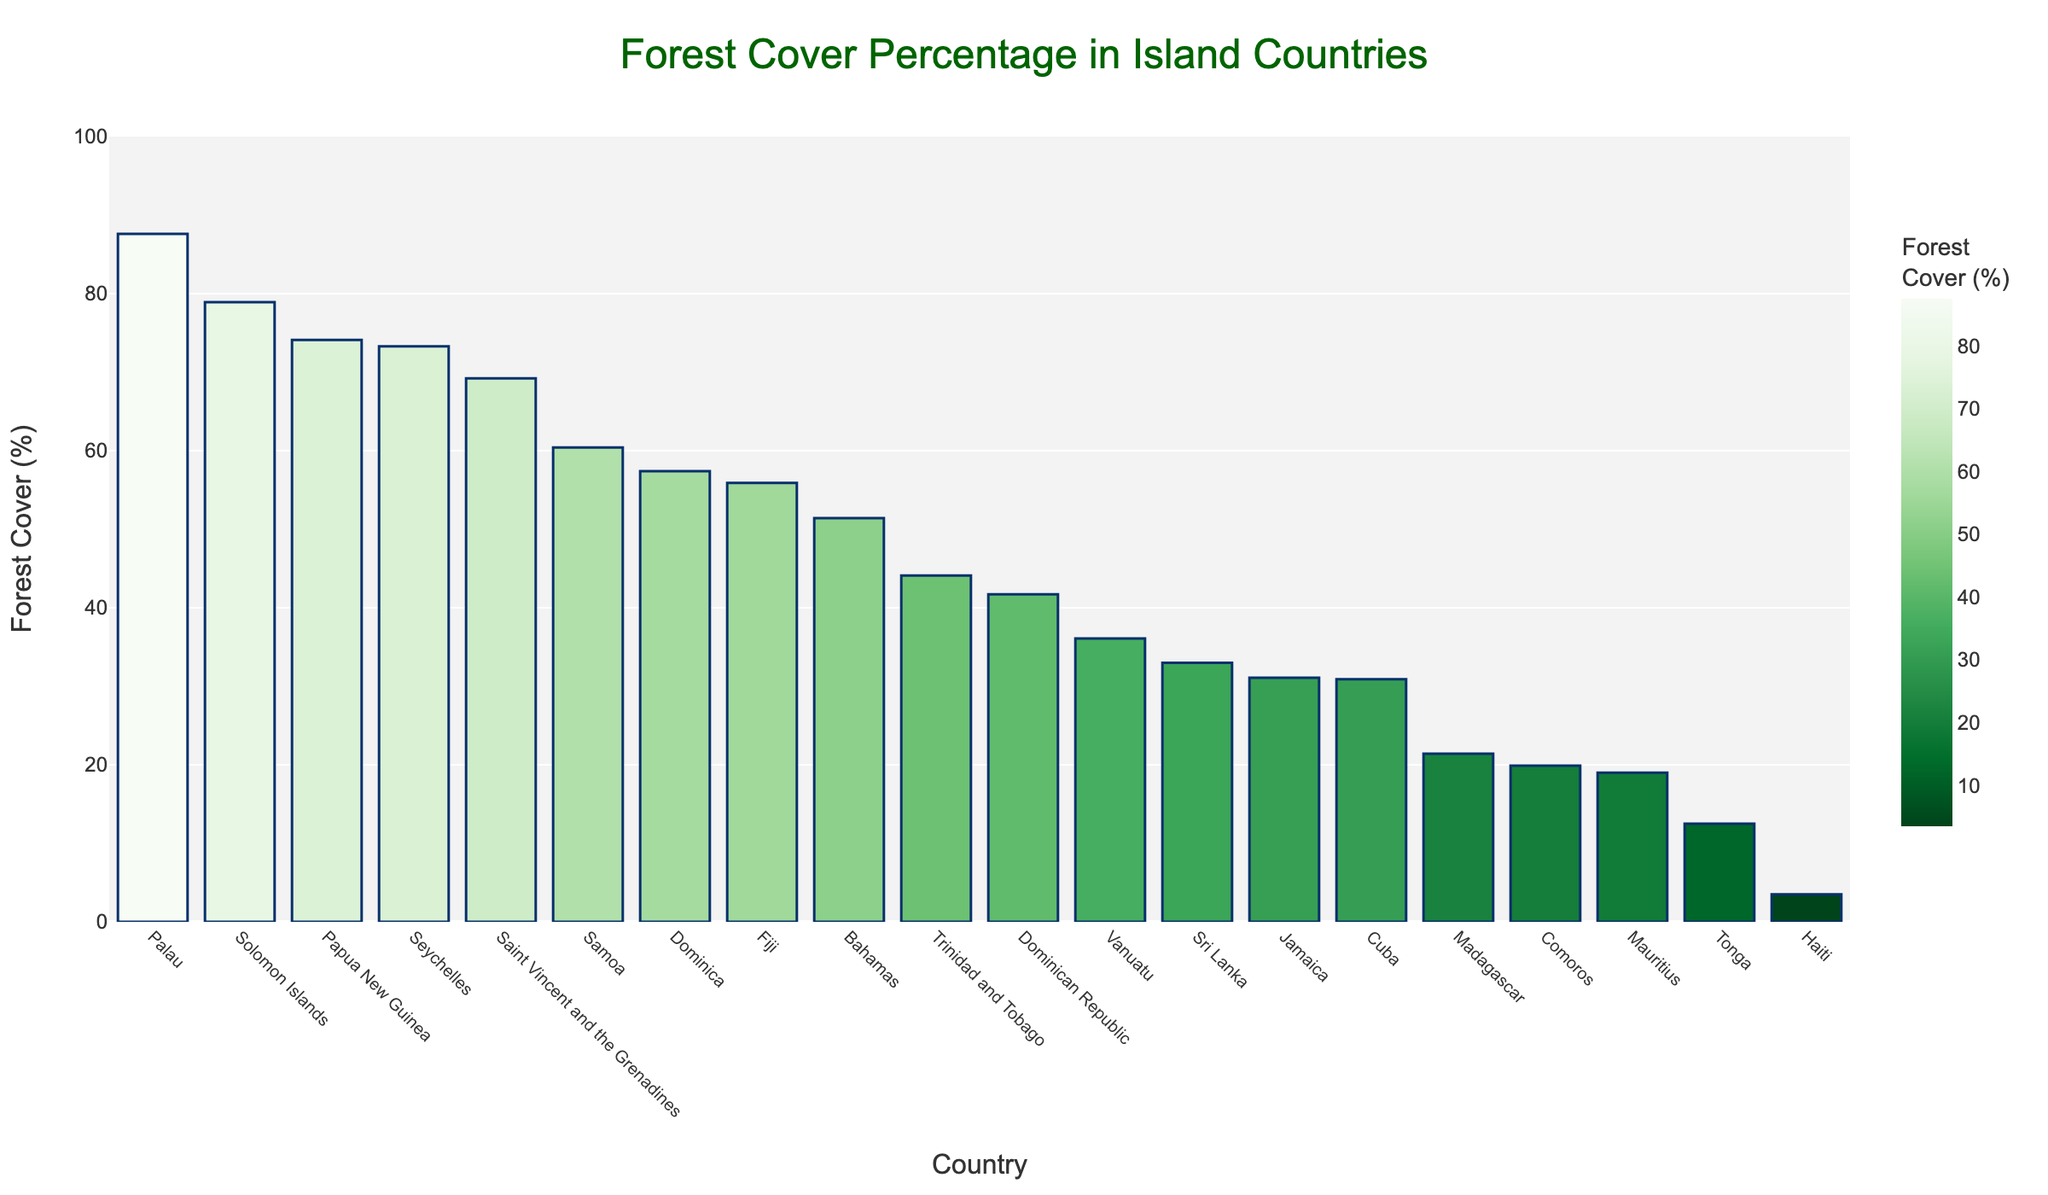What is the forest cover percentage of the country with the highest forested area? The highest bar represents Palau with a forest cover percentage of 87.6%.
Answer: 87.6% Which island country has the lowest forest cover percentage? The smallest bar represents Haiti with a forest cover percentage of 3.5%.
Answer: Haiti How many countries have a forest cover percentage above 50%? Counting the bars that exceed the 50% mark reveals that there are 10 countries with forest cover above 50%.
Answer: 10 Compare the forest cover percentage of Trinidad and Tobago to that of Jamaica. Which has a higher forest cover percentage? Trinidad and Tobago has a forest cover percentage of 44.1%, while Jamaica has 31.1%. Trinidad and Tobago has a higher forest cover percentage.
Answer: Trinidad and Tobago What is the median forest cover percentage of all the countries listed? To find the median, list all forest cover percentages in ascending order. The middle value of the sorted list is 44.1%, which is the value for Trinidad and Tobago.
Answer: 44.1% Calculate the difference in forest cover percentage between Solomon Islands and Tonga. Subtract Tonga's percentage (12.5%) from Solomon Islands' percentage (78.9%): 78.9% - 12.5% = 66.4%.
Answer: 66.4% Which countries have a forest cover percentage between 50% and 60%? The bars for the countries within the range of 50% to 60% are Fiji (55.9%), Dominica (57.4%), and Samoa (60.4%).
Answer: Fiji, Dominica, Samoa What is the combined forest cover percentage of Vanuatu and Cuba? Add the forest cover percentages of Vanuatu (36.1%) and Cuba (30.9%): 36.1% + 30.9% = 67%.
Answer: 67% Order the top three countries by forest cover percentage. The top three by decreasing forest cover are Palau (87.6%), Solomon Islands (78.9%), and Papua New Guinea (74.1%).
Answer: Palau, Solomon Islands, Papua New Guinea How much higher is the forest cover percentage in Seychelles compared to Madagascar? Subtract Madagascar's percentage (21.4%) from Seychelles' percentage (73.3%): 73.3% - 21.4% = 51.9%.
Answer: 51.9% 